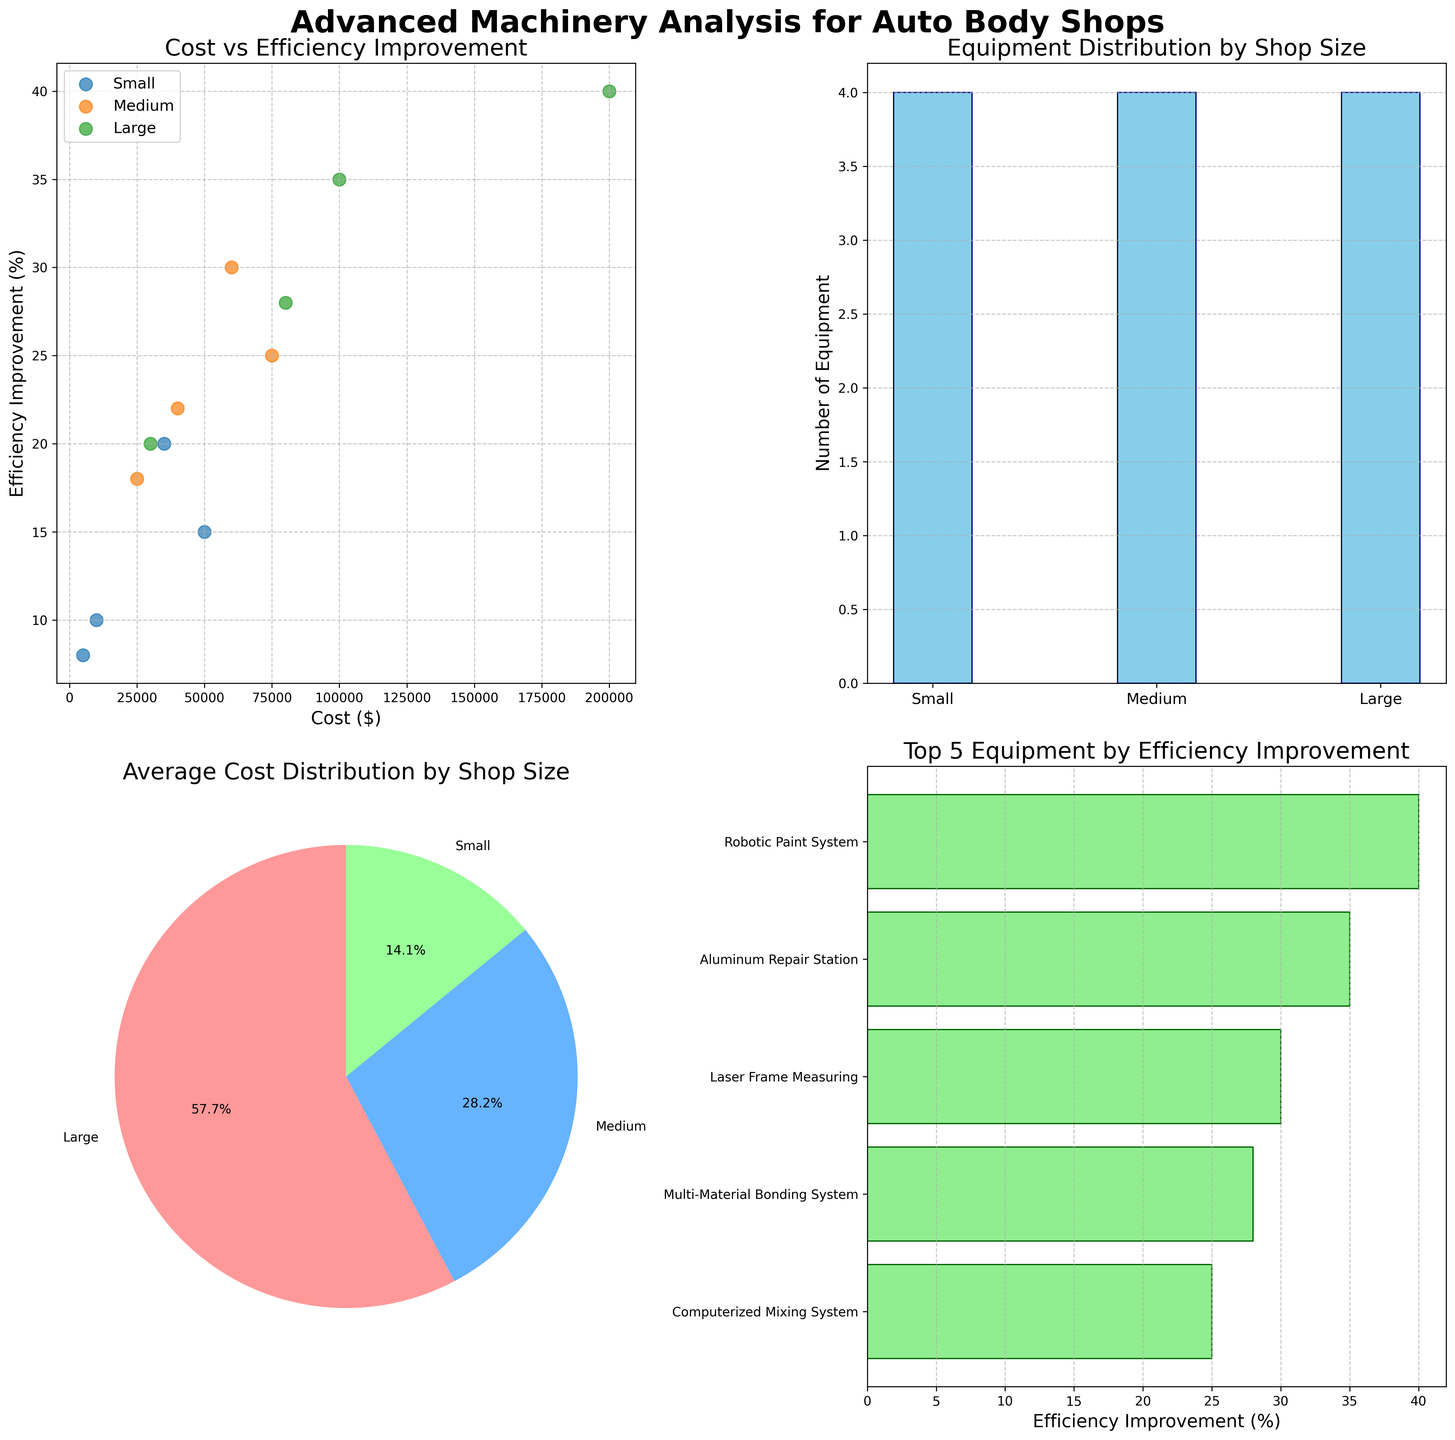What are the different shop sizes depicted in the plots? The shop sizes are provided in the legends and titles such as in the Cost vs Efficiency Improvement plot, where multiple scatter points are labeled by shop size. The bar charts also categorize the equipment and cost by shop size.
Answer: Small, Medium, Large Which shop size has the highest average cost distribution? In the pie chart (Plot 3), the distribution slices are labeled with their respective percentages for each shop size. By observing these slices, the largest one represents the shop size with the highest average cost.
Answer: Large How many types of equipment are visualized for each shop size? The Equipment Distribution by Shop Size (Plot 2) uses a bar chart to show the count of equipment types per shop size. Each bar's height represents the number of equipment types for Small, Medium, and Large shops.
Answer: Small: 4, Medium: 4, Large: 4 Which equipment shows the highest efficiency improvement, and what percentage is it? The Top 5 Equipment by Efficiency Improvement (Plot 4) uses a horizontal bar chart where the length represents the efficiency improvement percentage. The equipment with the longest bar has the highest improvement.
Answer: Robotic Paint System, 40% How does the cost of equipment correlate with the efficiency improvement for large shops? Referring to Plot 1, within the scatter points labeled ‘Large’, the general trend shows that higher costs correlate with higher efficiency improvements for large shops. The points for large shops demonstrate this relationship.
Answer: Positive correlation What percentage of average cost distribution is attributed to small shops? The pie chart (Plot 3) includes labeled slices showing percentages for each shop size. The percentage slice corresponding to small shops is the required value.
Answer: 17.7% Which shop size has the most types of advanced equipment? This can be seen in Plot 2 where the bar chart shows the number of equipment types by shop size. The tallest bar represents the shop size with the most equipment types.
Answer: All shop sizes have the same number of equipment types (4) Compare the efficiency improvement of the 'Laser Frame Measuring' and 'Advanced Dent Removal Tools'. In Plot 4 and Plot 1, you can see the efficiency improvement of each equipment. By cross-referencing the points and bars, identify and compare the efficiency improvements.
Answer: Laser Frame Measuring: 30%, Advanced Dent Removal Tools: 20% What's the relationship between shop size and efficiency improvement? Observing Plot 1, the scatter plot shows that larger shop sizes (Large) tend to have higher efficiency improvements while smaller shop sizes (Small) tend to have lower efficiencies.
Answer: Large shops generally have higher efficiency Is the '3D Wheel Alignment' more efficient than the 'Welding System'? By comparing their positions in the Top 5 Equipment bar chart (Plot 4) and the scatter plot (Plot 1), '3D Wheel Alignment' shows a higher efficiency improvement percentage than 'Welding System'.
Answer: Yes, 3D Wheel Alignment: 22%, Welding System: 10% 